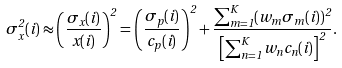Convert formula to latex. <formula><loc_0><loc_0><loc_500><loc_500>\sigma ^ { 2 } _ { x } ( i ) \approx \left ( \frac { \sigma _ { x } ( i ) } { x ( i ) } \right ) ^ { 2 } = \left ( \frac { \sigma _ { p } ( i ) } { c _ { p } ( i ) } \right ) ^ { 2 } + \frac { \sum _ { m = 1 } ^ { K } ( w _ { m } \sigma _ { m } ( i ) ) ^ { 2 } } { \left [ \sum _ { n = 1 } ^ { K } w _ { n } c _ { n } ( i ) \right ] ^ { 2 } } .</formula> 